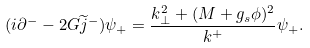Convert formula to latex. <formula><loc_0><loc_0><loc_500><loc_500>( i \partial ^ { - } - 2 G \widetilde { j } ^ { - } ) \psi _ { + } = \frac { k _ { \bot } ^ { 2 } + ( M + g _ { s } \phi ) ^ { 2 } } { k ^ { + } } \psi _ { + } .</formula> 